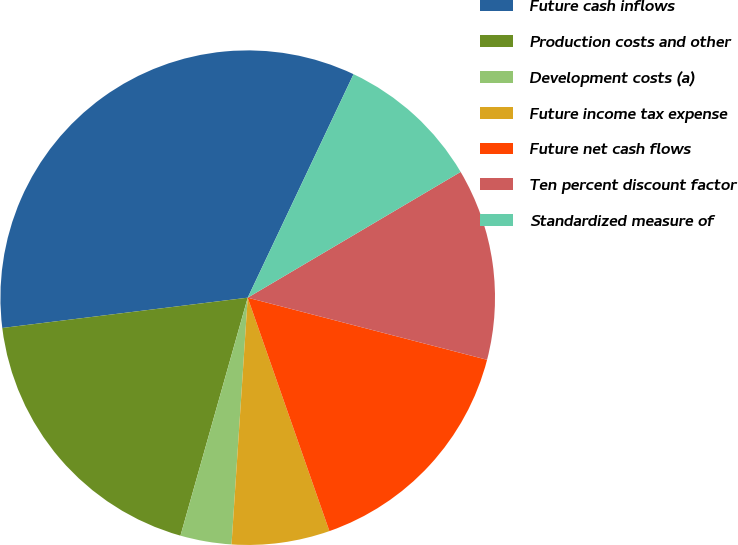<chart> <loc_0><loc_0><loc_500><loc_500><pie_chart><fcel>Future cash inflows<fcel>Production costs and other<fcel>Development costs (a)<fcel>Future income tax expense<fcel>Future net cash flows<fcel>Ten percent discount factor<fcel>Standardized measure of<nl><fcel>33.99%<fcel>18.66%<fcel>3.34%<fcel>6.4%<fcel>15.6%<fcel>12.53%<fcel>9.47%<nl></chart> 